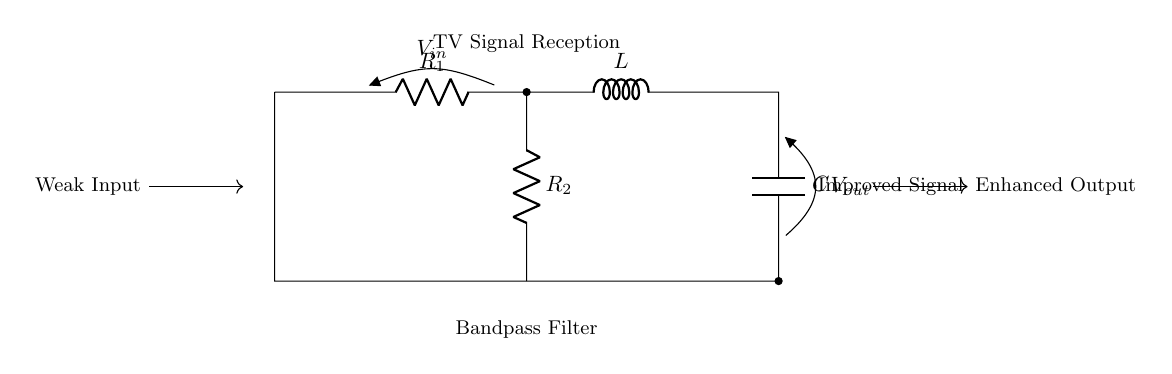What components are in the circuit? The circuit contains a resistor, an inductor, and a capacitor, as indicated by the labels R, L, and C.
Answer: Resistor, Inductor, Capacitor What is the purpose of this circuit? The purpose of the circuit is to serve as a bandpass filter that improves TV signal reception. This is indicated by the label "Bandpass Filter" and the context of enhancing signal quality for TV reception.
Answer: Improve TV signal reception What is the voltage at the input? The voltage at the input is denoted as V_in, which is the voltage supplied to the circuit from the weak input signal.
Answer: V_in Which component is connected directly to the output? The component connected directly to the output is the capacitor, as indicated by the connection and label for V_out.
Answer: Capacitor What does R_2 indicate in the circuit? R_2 is another resistor in the circuit that likely helps in determining the filter characteristics by interacting with the inductor and the capacitor.
Answer: A resistor How does this circuit improve signal quality? The circuit improves signal quality by filtering out unwanted frequencies while allowing desired frequencies to pass through, which is a function of the resistor, inductor, and capacitor working together in the bandpass filter configuration.
Answer: By filtering frequencies What type of circuit is this? This is an RLC circuit, which refers to the specific combination of resistors, inductors, and capacitors used to create a bandpass filter for tuning signals.
Answer: RLC circuit 